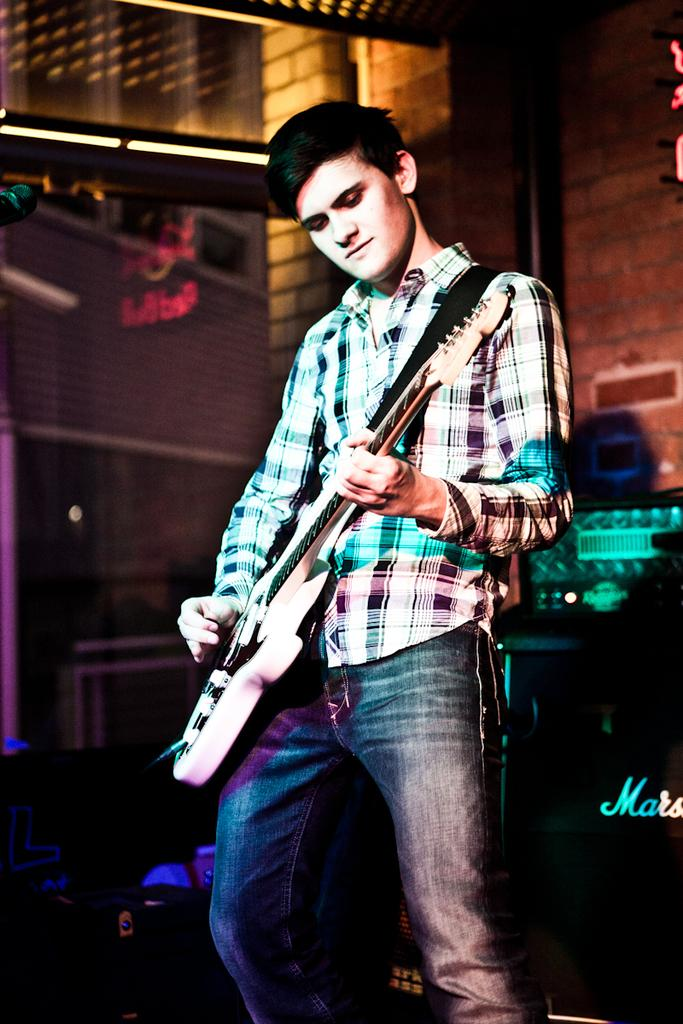Who is the person in the image? The person in the image is identified as "Mike." What is Mike doing in the image? Mike is playing a guitar in the image. What can be seen in the background of the image? There is a wall in the background of the image. What else is visible in the image? There are lights visible in the image. What color is the crayon that Mike is using to draw on the wall in the image? There is no crayon present in the image, and Mike is playing a guitar, not drawing on the wall. 